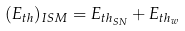<formula> <loc_0><loc_0><loc_500><loc_500>( E _ { t h } ) _ { I S M } = E _ { t h _ { S N } } + E _ { t h _ { w } }</formula> 